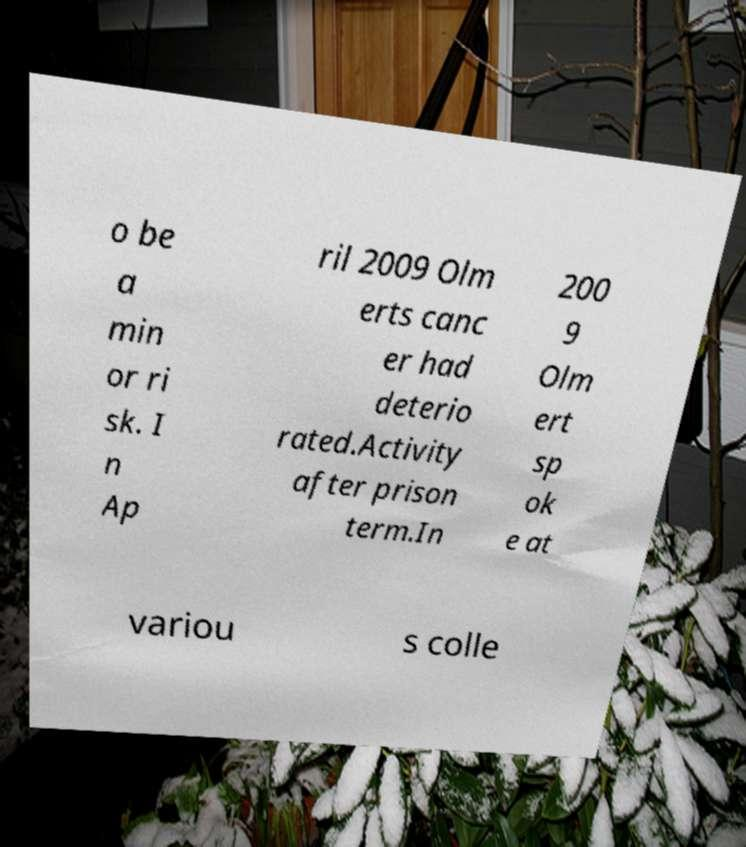I need the written content from this picture converted into text. Can you do that? o be a min or ri sk. I n Ap ril 2009 Olm erts canc er had deterio rated.Activity after prison term.In 200 9 Olm ert sp ok e at variou s colle 